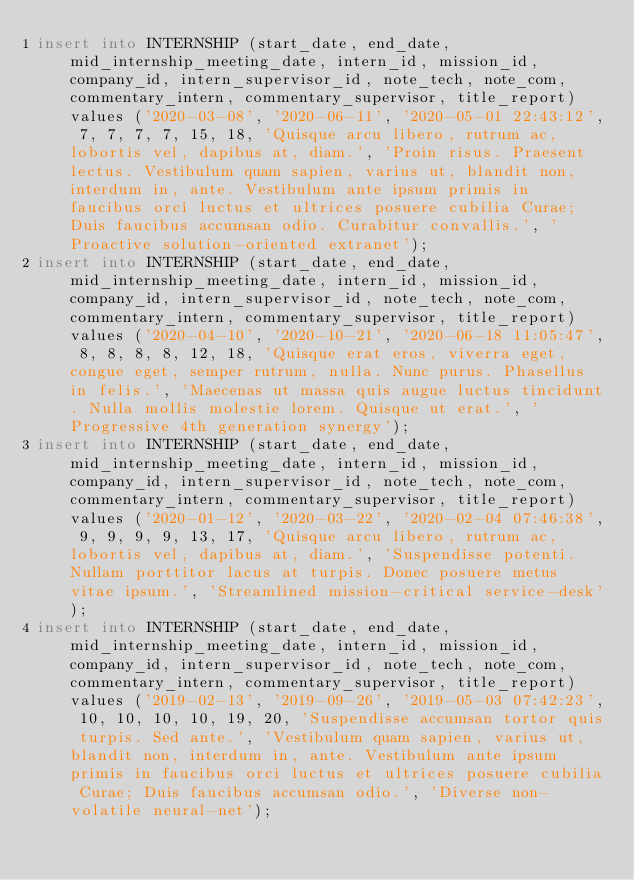Convert code to text. <code><loc_0><loc_0><loc_500><loc_500><_SQL_>insert into INTERNSHIP (start_date, end_date, mid_internship_meeting_date, intern_id, mission_id, company_id, intern_supervisor_id, note_tech, note_com, commentary_intern, commentary_supervisor, title_report) values ('2020-03-08', '2020-06-11', '2020-05-01 22:43:12', 7, 7, 7, 7, 15, 18, 'Quisque arcu libero, rutrum ac, lobortis vel, dapibus at, diam.', 'Proin risus. Praesent lectus. Vestibulum quam sapien, varius ut, blandit non, interdum in, ante. Vestibulum ante ipsum primis in faucibus orci luctus et ultrices posuere cubilia Curae; Duis faucibus accumsan odio. Curabitur convallis.', 'Proactive solution-oriented extranet');
insert into INTERNSHIP (start_date, end_date, mid_internship_meeting_date, intern_id, mission_id, company_id, intern_supervisor_id, note_tech, note_com, commentary_intern, commentary_supervisor, title_report) values ('2020-04-10', '2020-10-21', '2020-06-18 11:05:47', 8, 8, 8, 8, 12, 18, 'Quisque erat eros, viverra eget, congue eget, semper rutrum, nulla. Nunc purus. Phasellus in felis.', 'Maecenas ut massa quis augue luctus tincidunt. Nulla mollis molestie lorem. Quisque ut erat.', 'Progressive 4th generation synergy');
insert into INTERNSHIP (start_date, end_date, mid_internship_meeting_date, intern_id, mission_id, company_id, intern_supervisor_id, note_tech, note_com, commentary_intern, commentary_supervisor, title_report) values ('2020-01-12', '2020-03-22', '2020-02-04 07:46:38', 9, 9, 9, 9, 13, 17, 'Quisque arcu libero, rutrum ac, lobortis vel, dapibus at, diam.', 'Suspendisse potenti. Nullam porttitor lacus at turpis. Donec posuere metus vitae ipsum.', 'Streamlined mission-critical service-desk');
insert into INTERNSHIP (start_date, end_date, mid_internship_meeting_date, intern_id, mission_id, company_id, intern_supervisor_id, note_tech, note_com, commentary_intern, commentary_supervisor, title_report) values ('2019-02-13', '2019-09-26', '2019-05-03 07:42:23', 10, 10, 10, 10, 19, 20, 'Suspendisse accumsan tortor quis turpis. Sed ante.', 'Vestibulum quam sapien, varius ut, blandit non, interdum in, ante. Vestibulum ante ipsum primis in faucibus orci luctus et ultrices posuere cubilia Curae; Duis faucibus accumsan odio.', 'Diverse non-volatile neural-net');</code> 